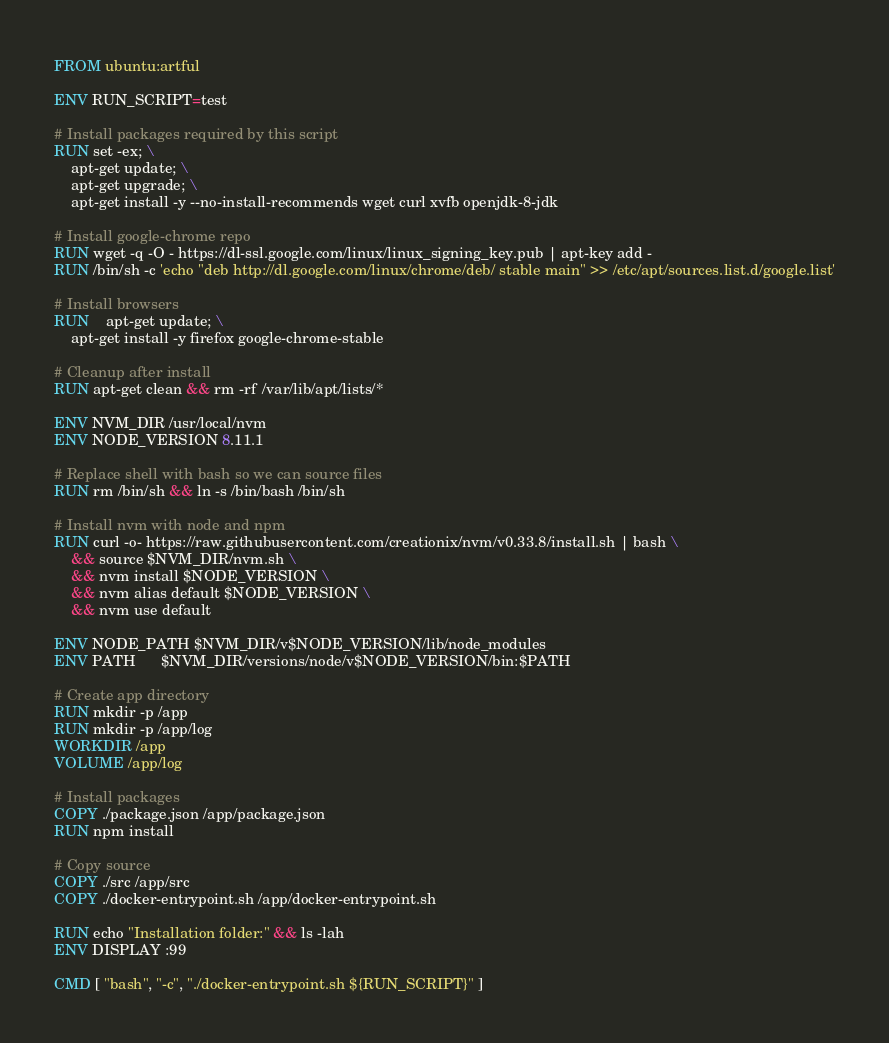<code> <loc_0><loc_0><loc_500><loc_500><_Dockerfile_>FROM ubuntu:artful

ENV RUN_SCRIPT=test

# Install packages required by this script
RUN set -ex; \
	apt-get update; \
	apt-get upgrade; \
	apt-get install -y --no-install-recommends wget curl xvfb openjdk-8-jdk

# Install google-chrome repo
RUN wget -q -O - https://dl-ssl.google.com/linux/linux_signing_key.pub | apt-key add -
RUN /bin/sh -c 'echo "deb http://dl.google.com/linux/chrome/deb/ stable main" >> /etc/apt/sources.list.d/google.list'

# Install browsers
RUN	apt-get update; \
    apt-get install -y firefox google-chrome-stable

# Cleanup after install
RUN apt-get clean && rm -rf /var/lib/apt/lists/*

ENV NVM_DIR /usr/local/nvm
ENV NODE_VERSION 8.11.1

# Replace shell with bash so we can source files
RUN rm /bin/sh && ln -s /bin/bash /bin/sh

# Install nvm with node and npm
RUN curl -o- https://raw.githubusercontent.com/creationix/nvm/v0.33.8/install.sh | bash \
    && source $NVM_DIR/nvm.sh \
    && nvm install $NODE_VERSION \
    && nvm alias default $NODE_VERSION \
    && nvm use default

ENV NODE_PATH $NVM_DIR/v$NODE_VERSION/lib/node_modules
ENV PATH      $NVM_DIR/versions/node/v$NODE_VERSION/bin:$PATH

# Create app directory
RUN mkdir -p /app
RUN mkdir -p /app/log
WORKDIR /app
VOLUME /app/log

# Install packages
COPY ./package.json /app/package.json
RUN npm install

# Copy source
COPY ./src /app/src
COPY ./docker-entrypoint.sh /app/docker-entrypoint.sh

RUN echo "Installation folder:" && ls -lah
ENV DISPLAY :99

CMD [ "bash", "-c", "./docker-entrypoint.sh ${RUN_SCRIPT}" ]
</code> 